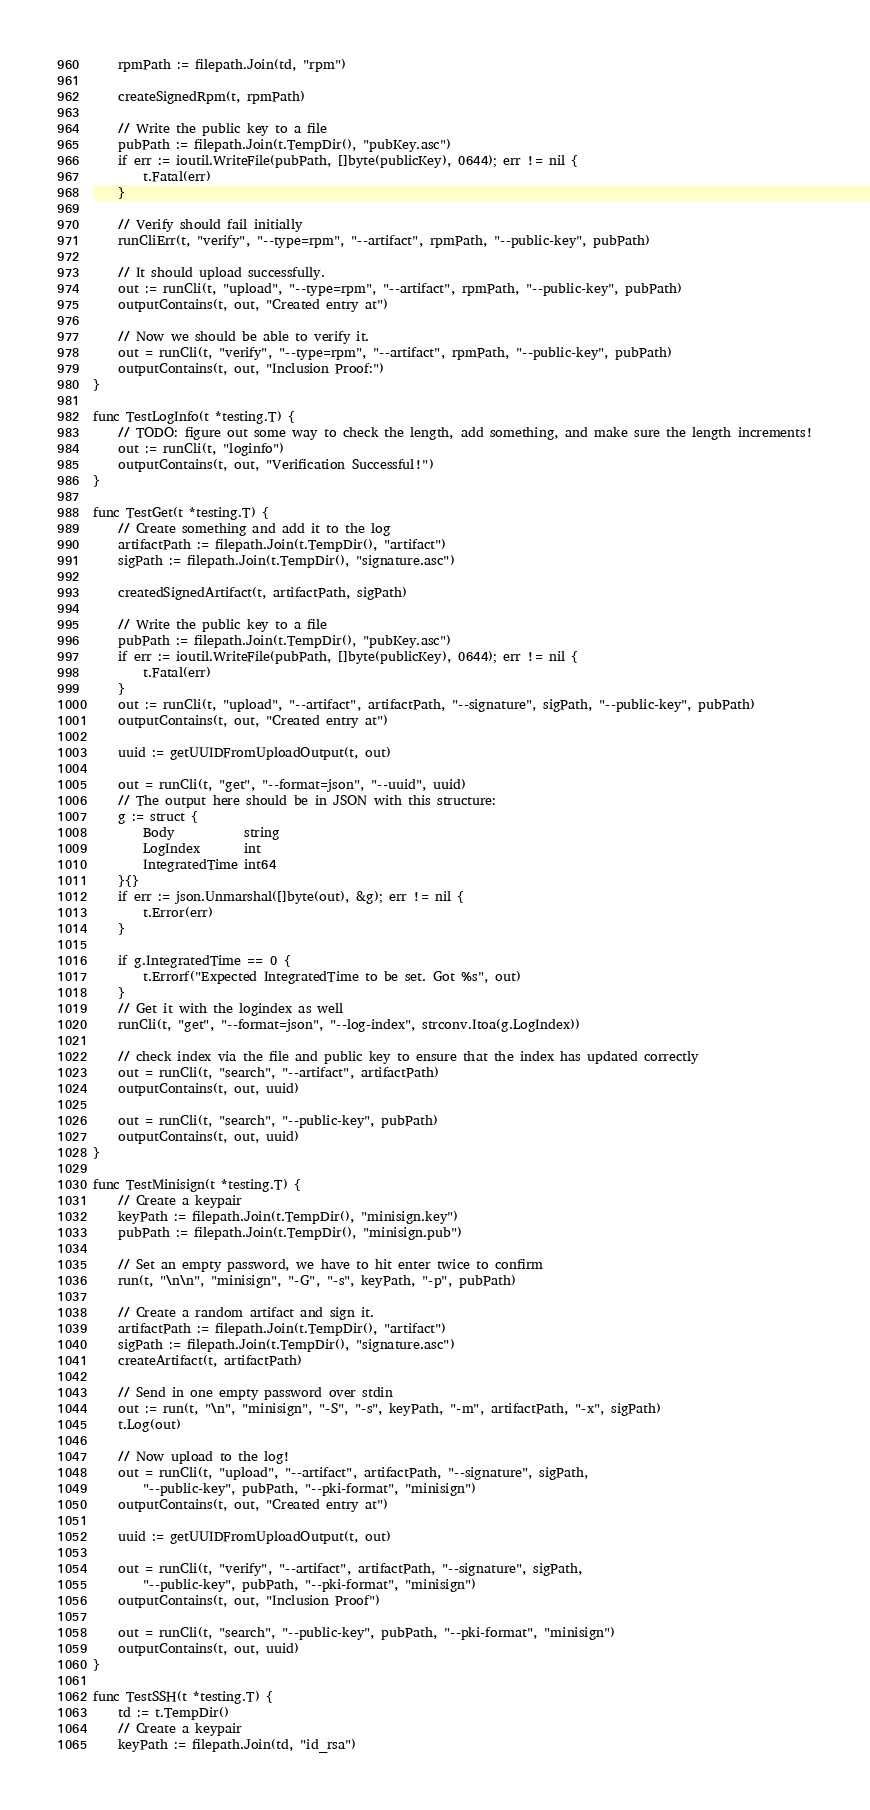<code> <loc_0><loc_0><loc_500><loc_500><_Go_>	rpmPath := filepath.Join(td, "rpm")

	createSignedRpm(t, rpmPath)

	// Write the public key to a file
	pubPath := filepath.Join(t.TempDir(), "pubKey.asc")
	if err := ioutil.WriteFile(pubPath, []byte(publicKey), 0644); err != nil {
		t.Fatal(err)
	}

	// Verify should fail initially
	runCliErr(t, "verify", "--type=rpm", "--artifact", rpmPath, "--public-key", pubPath)

	// It should upload successfully.
	out := runCli(t, "upload", "--type=rpm", "--artifact", rpmPath, "--public-key", pubPath)
	outputContains(t, out, "Created entry at")

	// Now we should be able to verify it.
	out = runCli(t, "verify", "--type=rpm", "--artifact", rpmPath, "--public-key", pubPath)
	outputContains(t, out, "Inclusion Proof:")
}

func TestLogInfo(t *testing.T) {
	// TODO: figure out some way to check the length, add something, and make sure the length increments!
	out := runCli(t, "loginfo")
	outputContains(t, out, "Verification Successful!")
}

func TestGet(t *testing.T) {
	// Create something and add it to the log
	artifactPath := filepath.Join(t.TempDir(), "artifact")
	sigPath := filepath.Join(t.TempDir(), "signature.asc")

	createdSignedArtifact(t, artifactPath, sigPath)

	// Write the public key to a file
	pubPath := filepath.Join(t.TempDir(), "pubKey.asc")
	if err := ioutil.WriteFile(pubPath, []byte(publicKey), 0644); err != nil {
		t.Fatal(err)
	}
	out := runCli(t, "upload", "--artifact", artifactPath, "--signature", sigPath, "--public-key", pubPath)
	outputContains(t, out, "Created entry at")

	uuid := getUUIDFromUploadOutput(t, out)

	out = runCli(t, "get", "--format=json", "--uuid", uuid)
	// The output here should be in JSON with this structure:
	g := struct {
		Body           string
		LogIndex       int
		IntegratedTime int64
	}{}
	if err := json.Unmarshal([]byte(out), &g); err != nil {
		t.Error(err)
	}

	if g.IntegratedTime == 0 {
		t.Errorf("Expected IntegratedTime to be set. Got %s", out)
	}
	// Get it with the logindex as well
	runCli(t, "get", "--format=json", "--log-index", strconv.Itoa(g.LogIndex))

	// check index via the file and public key to ensure that the index has updated correctly
	out = runCli(t, "search", "--artifact", artifactPath)
	outputContains(t, out, uuid)

	out = runCli(t, "search", "--public-key", pubPath)
	outputContains(t, out, uuid)
}

func TestMinisign(t *testing.T) {
	// Create a keypair
	keyPath := filepath.Join(t.TempDir(), "minisign.key")
	pubPath := filepath.Join(t.TempDir(), "minisign.pub")

	// Set an empty password, we have to hit enter twice to confirm
	run(t, "\n\n", "minisign", "-G", "-s", keyPath, "-p", pubPath)

	// Create a random artifact and sign it.
	artifactPath := filepath.Join(t.TempDir(), "artifact")
	sigPath := filepath.Join(t.TempDir(), "signature.asc")
	createArtifact(t, artifactPath)

	// Send in one empty password over stdin
	out := run(t, "\n", "minisign", "-S", "-s", keyPath, "-m", artifactPath, "-x", sigPath)
	t.Log(out)

	// Now upload to the log!
	out = runCli(t, "upload", "--artifact", artifactPath, "--signature", sigPath,
		"--public-key", pubPath, "--pki-format", "minisign")
	outputContains(t, out, "Created entry at")

	uuid := getUUIDFromUploadOutput(t, out)

	out = runCli(t, "verify", "--artifact", artifactPath, "--signature", sigPath,
		"--public-key", pubPath, "--pki-format", "minisign")
	outputContains(t, out, "Inclusion Proof")

	out = runCli(t, "search", "--public-key", pubPath, "--pki-format", "minisign")
	outputContains(t, out, uuid)
}

func TestSSH(t *testing.T) {
	td := t.TempDir()
	// Create a keypair
	keyPath := filepath.Join(td, "id_rsa")</code> 